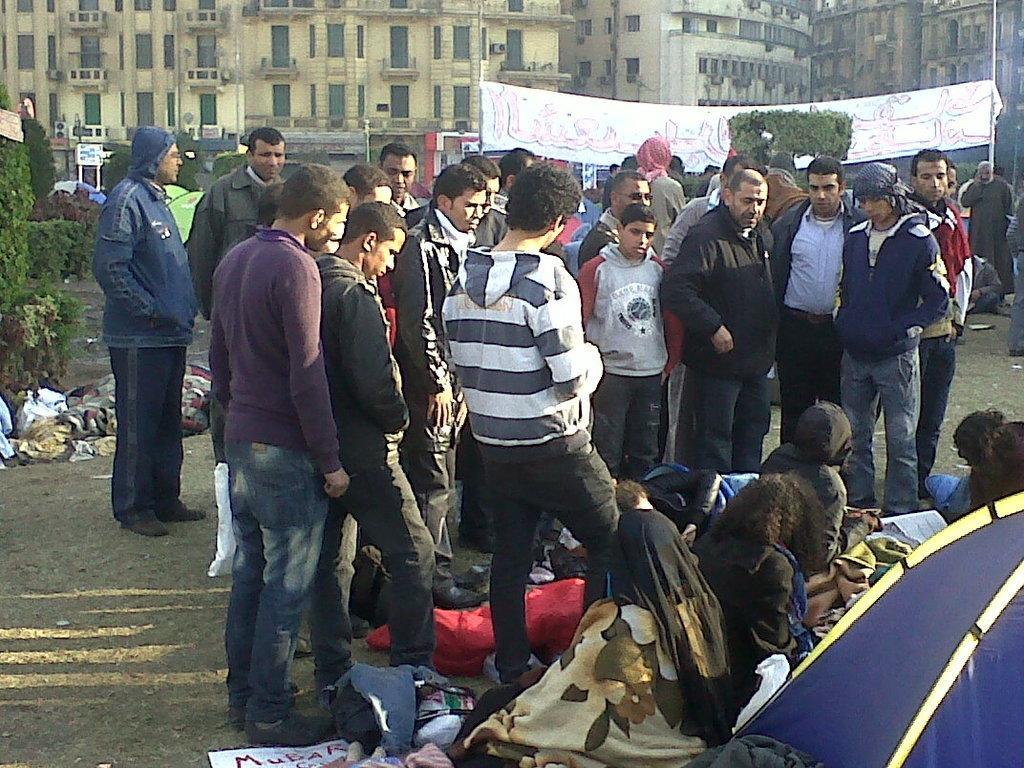Describe this image in one or two sentences. In this picture, there are group of people. Some of them are sitting on the ground and some of them are standing. In the center, there is a man wearing a striped jacket. Behind him, there are two men. At the bottom right, there is a tent. Behind the group of people, there is a banner with some text. In the background, there are trees and buildings. 